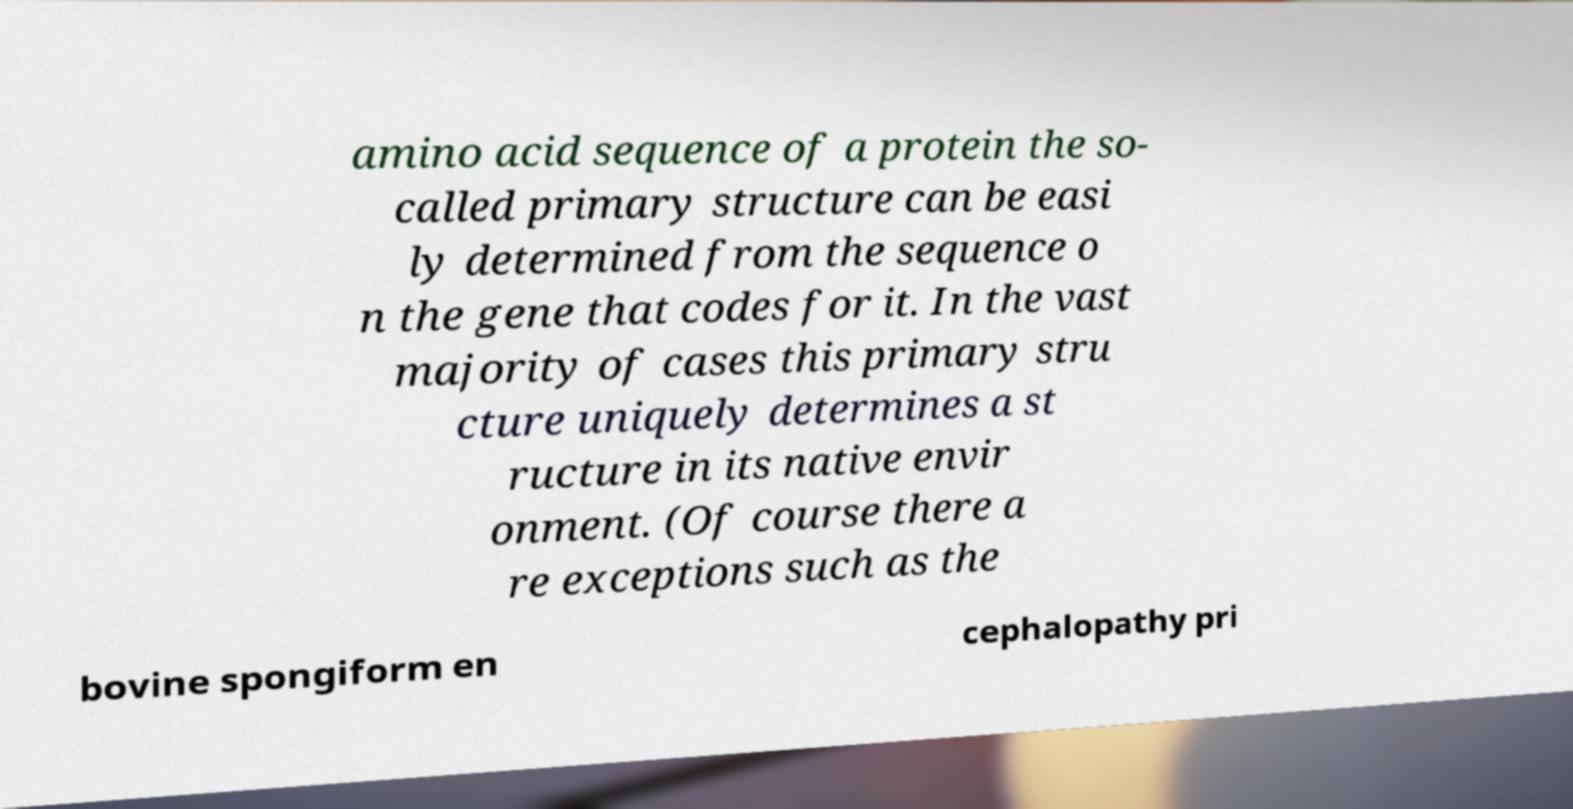Please read and relay the text visible in this image. What does it say? amino acid sequence of a protein the so- called primary structure can be easi ly determined from the sequence o n the gene that codes for it. In the vast majority of cases this primary stru cture uniquely determines a st ructure in its native envir onment. (Of course there a re exceptions such as the bovine spongiform en cephalopathy pri 